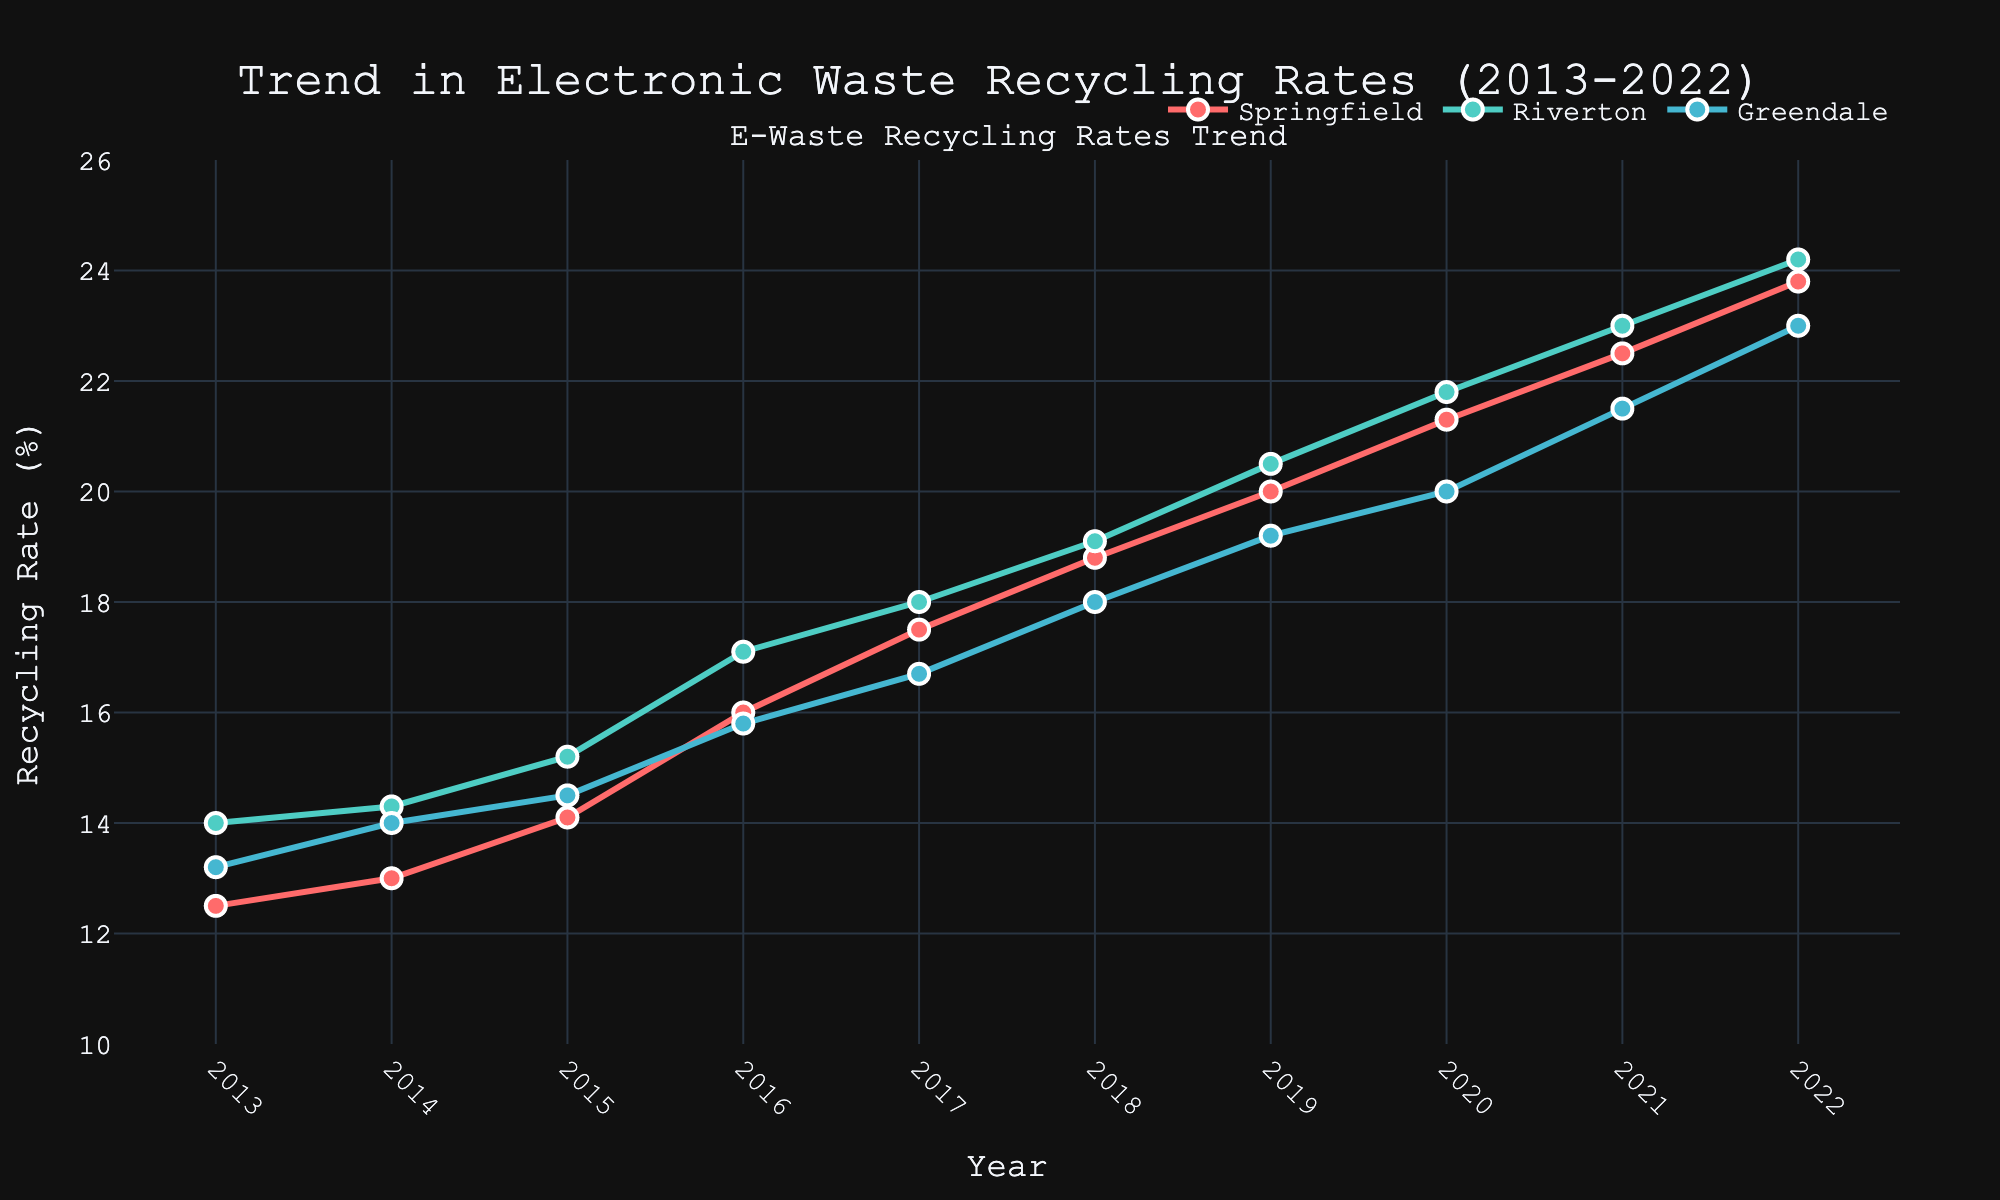What is the overall trend in the recycling rates for the communities over the last decade? All three communities (Springfield, Riverton, and Greendale) show a clear upward trend in their recycling rates from 2013 to 2022. Springfield climbs from 12.5% to 23.8%, Riverton from 14.0% to 24.2%, and Greendale from 13.2% to 23.0%. This indicates a positive trend in recycling behaviors across all communities.
Answer: Upward Which community had the highest recycling rate in 2022? In 2022, Riverton had the highest recycling rate. Observing the 2022 data points, Riverton reached 24.2%, while Springfield and Greendale were at 23.8% and 23.0% respectively.
Answer: Riverton How did Greendale's recycling rate change from 2013 to 2022? In 2013, Greendale's recycling rate was 13.2%, and by 2022, it had increased to 23.0%. This represents an increase of 9.8 percentage points over the decade.
Answer: Increased by 9.8 percentage points Which year saw the largest increase in Springfield's recycling rate? The largest increase in Springfield's recycling rate appeared between 2016 and 2017, where the rate jumped from 16.0% to 17.5%. This is a 1.5 percentage point increase, the highest year-over-year change for Springfield.
Answer: Between 2016 and 2017 On average, how does Springfield's recycling rate growth compare with Greendale's over the decade? To find the average growth per year for each community over the decade, we subtract their 2013 rate from their 2022 rate and divide by 9 (number of increments). For Springfield: (23.8 - 12.5) / 9 = 1.25% per year. For Greendale: (23.0 - 13.2) / 9 = 1.09% per year. Springfield's rate has a higher average yearly growth compared to Greendale's rate.
Answer: Springfield's average yearly growth is higher By what percentage did Riverton's recycling rate increase from 2013 to 2022? Riverton's recycling rate in 2013 was 14.0%, and in 2022, it was 24.2%. The percentage increase can be calculated as ((24.2 - 14.0) / 14.0) * 100% = 72.86%.
Answer: 72.86% Which community had the most significant improvement in recycling rates from 2013 to 2022? By examining the absolute increase from 2013 to 2022, Springfield improved by 11.3 percentage points (23.8% - 12.5%), Riverton improved by 10.2 percentage points (24.2% - 14.0%), and Greendale improved by 9.8 percentage points (23.0% - 13.2%). Thus, Springfield had the most significant improvement.
Answer: Springfield What is the difference in recycling rates between Springfield and Riverton in 2020? In 2020, Springfield had a recycling rate of 21.3%, and Riverton had a rate of 21.8%. The difference between them is 21.8% - 21.3% = 0.5%.
Answer: 0.5% During which years did all three communities see an increase in recycling rates compared to the previous year? From the plot, it is evident that every year from 2013 to 2022, all three communities saw an increase in their recycling rates compared to the previous year. This is consistent across all communities.
Answer: Every year from 2013 to 2022 